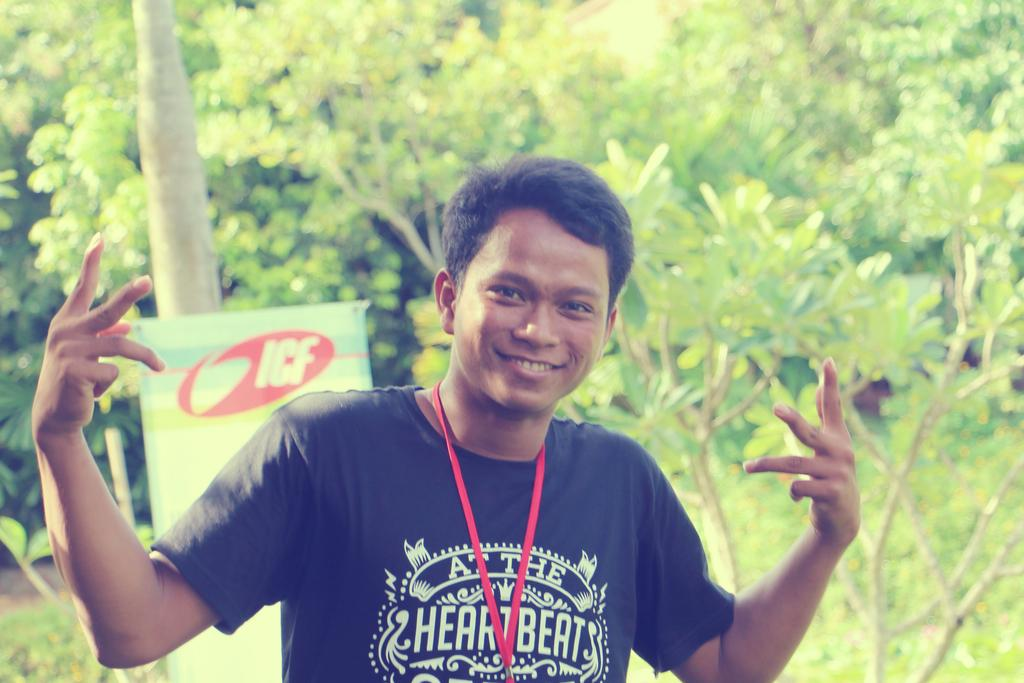Who or what is the main subject in the image? There is a person in the image. What is located behind the person in the image? There is a banner with text behind the person. What type of vegetation can be seen in the image? There are plants and trees in the image. Where is the cushion placed in the image? There is no cushion present in the image. How many books are visible in the image? There are no books visible in the image. 